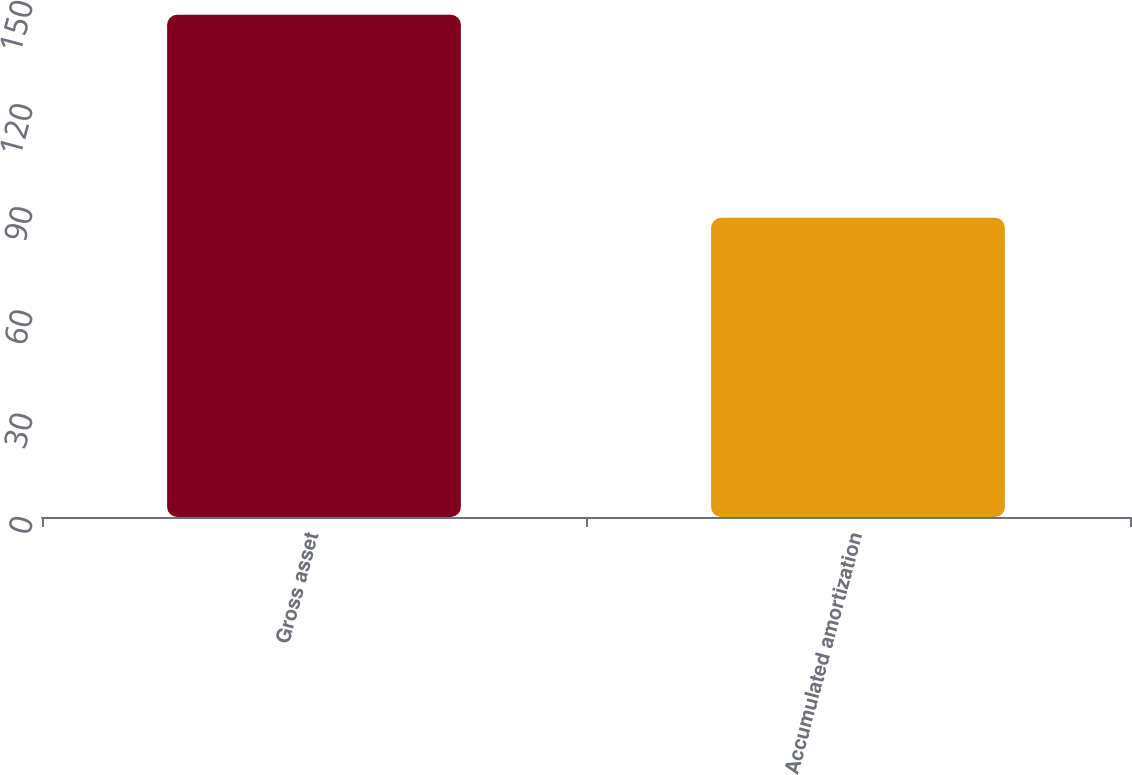Convert chart to OTSL. <chart><loc_0><loc_0><loc_500><loc_500><bar_chart><fcel>Gross asset<fcel>Accumulated amortization<nl><fcel>146<fcel>87<nl></chart> 